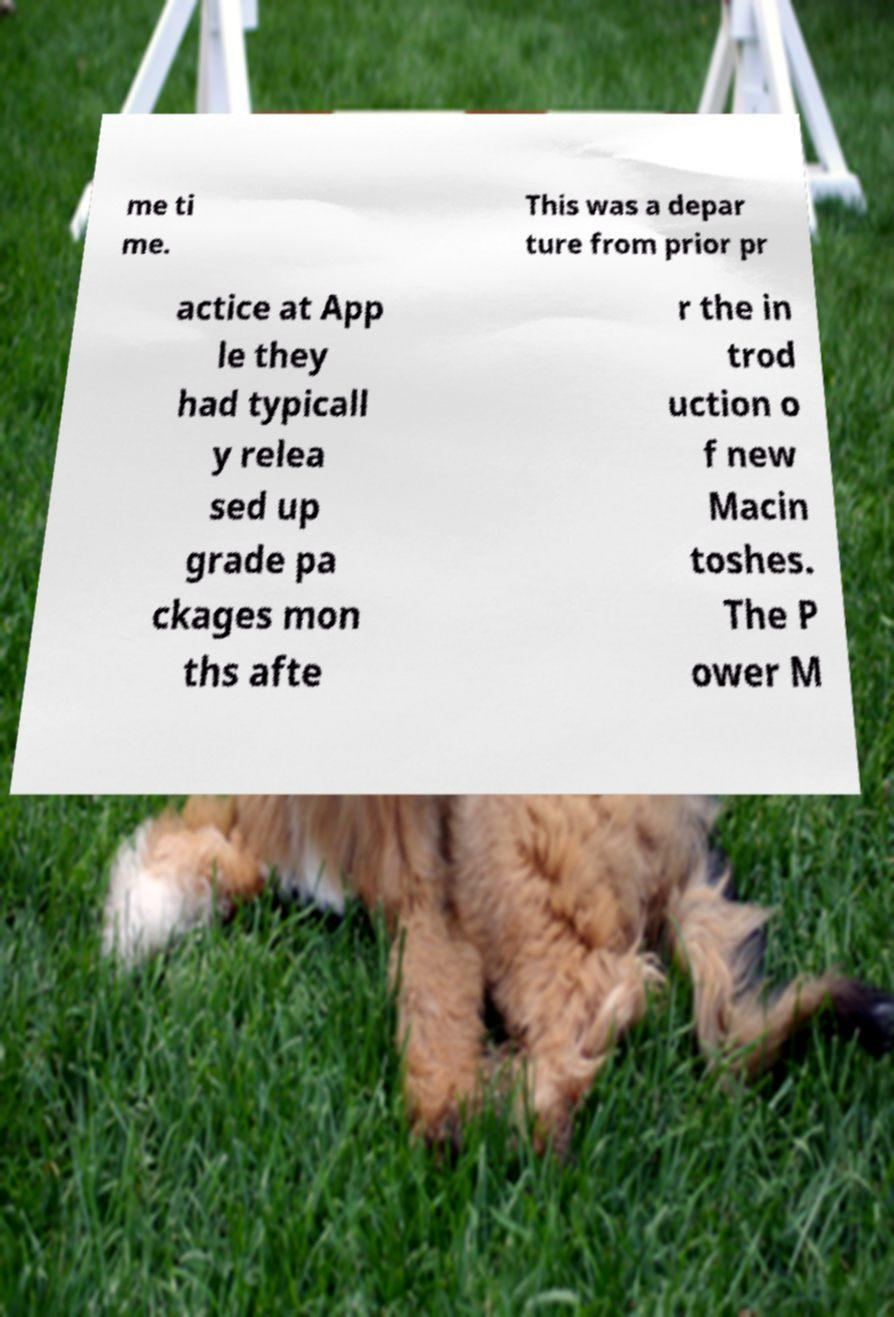Can you accurately transcribe the text from the provided image for me? me ti me. This was a depar ture from prior pr actice at App le they had typicall y relea sed up grade pa ckages mon ths afte r the in trod uction o f new Macin toshes. The P ower M 